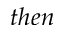<formula> <loc_0><loc_0><loc_500><loc_500>t h e n</formula> 